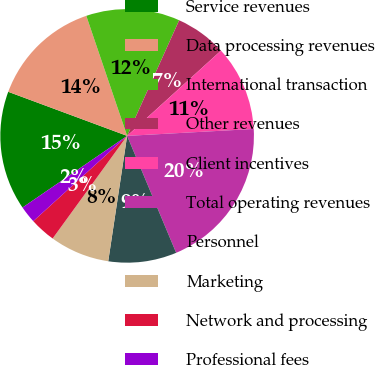Convert chart to OTSL. <chart><loc_0><loc_0><loc_500><loc_500><pie_chart><fcel>Service revenues<fcel>Data processing revenues<fcel>International transaction<fcel>Other revenues<fcel>Client incentives<fcel>Total operating revenues<fcel>Personnel<fcel>Marketing<fcel>Network and processing<fcel>Professional fees<nl><fcel>15.21%<fcel>14.13%<fcel>11.95%<fcel>6.53%<fcel>10.87%<fcel>19.55%<fcel>8.7%<fcel>7.61%<fcel>3.27%<fcel>2.18%<nl></chart> 